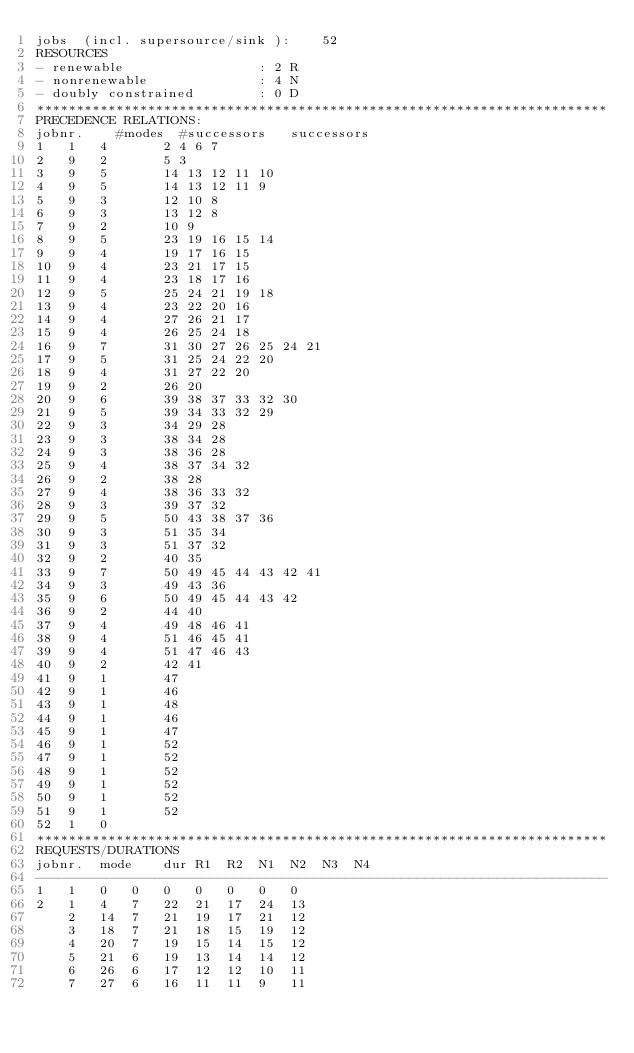Convert code to text. <code><loc_0><loc_0><loc_500><loc_500><_ObjectiveC_>jobs  (incl. supersource/sink ):	52
RESOURCES
- renewable                 : 2 R
- nonrenewable              : 4 N
- doubly constrained        : 0 D
************************************************************************
PRECEDENCE RELATIONS:
jobnr.    #modes  #successors   successors
1	1	4		2 4 6 7 
2	9	2		5 3 
3	9	5		14 13 12 11 10 
4	9	5		14 13 12 11 9 
5	9	3		12 10 8 
6	9	3		13 12 8 
7	9	2		10 9 
8	9	5		23 19 16 15 14 
9	9	4		19 17 16 15 
10	9	4		23 21 17 15 
11	9	4		23 18 17 16 
12	9	5		25 24 21 19 18 
13	9	4		23 22 20 16 
14	9	4		27 26 21 17 
15	9	4		26 25 24 18 
16	9	7		31 30 27 26 25 24 21 
17	9	5		31 25 24 22 20 
18	9	4		31 27 22 20 
19	9	2		26 20 
20	9	6		39 38 37 33 32 30 
21	9	5		39 34 33 32 29 
22	9	3		34 29 28 
23	9	3		38 34 28 
24	9	3		38 36 28 
25	9	4		38 37 34 32 
26	9	2		38 28 
27	9	4		38 36 33 32 
28	9	3		39 37 32 
29	9	5		50 43 38 37 36 
30	9	3		51 35 34 
31	9	3		51 37 32 
32	9	2		40 35 
33	9	7		50 49 45 44 43 42 41 
34	9	3		49 43 36 
35	9	6		50 49 45 44 43 42 
36	9	2		44 40 
37	9	4		49 48 46 41 
38	9	4		51 46 45 41 
39	9	4		51 47 46 43 
40	9	2		42 41 
41	9	1		47 
42	9	1		46 
43	9	1		48 
44	9	1		46 
45	9	1		47 
46	9	1		52 
47	9	1		52 
48	9	1		52 
49	9	1		52 
50	9	1		52 
51	9	1		52 
52	1	0		
************************************************************************
REQUESTS/DURATIONS
jobnr.	mode	dur	R1	R2	N1	N2	N3	N4	
------------------------------------------------------------------------
1	1	0	0	0	0	0	0	0	
2	1	4	7	22	21	17	24	13	
	2	14	7	21	19	17	21	12	
	3	18	7	21	18	15	19	12	
	4	20	7	19	15	14	15	12	
	5	21	6	19	13	14	14	12	
	6	26	6	17	12	12	10	11	
	7	27	6	16	11	11	9	11	</code> 